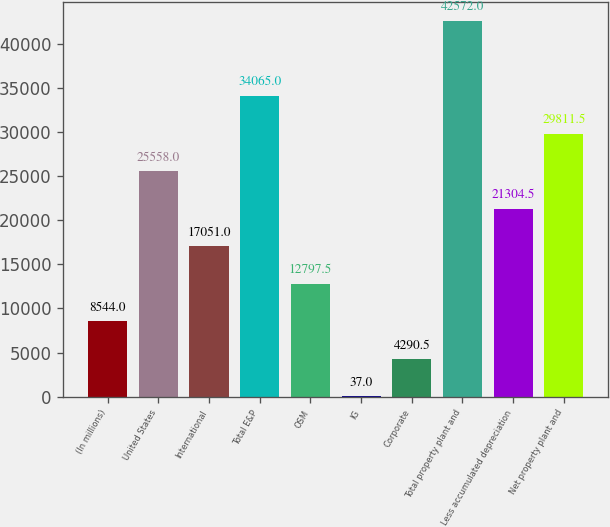Convert chart to OTSL. <chart><loc_0><loc_0><loc_500><loc_500><bar_chart><fcel>(In millions)<fcel>United States<fcel>International<fcel>Total E&P<fcel>OSM<fcel>IG<fcel>Corporate<fcel>Total property plant and<fcel>Less accumulated depreciation<fcel>Net property plant and<nl><fcel>8544<fcel>25558<fcel>17051<fcel>34065<fcel>12797.5<fcel>37<fcel>4290.5<fcel>42572<fcel>21304.5<fcel>29811.5<nl></chart> 